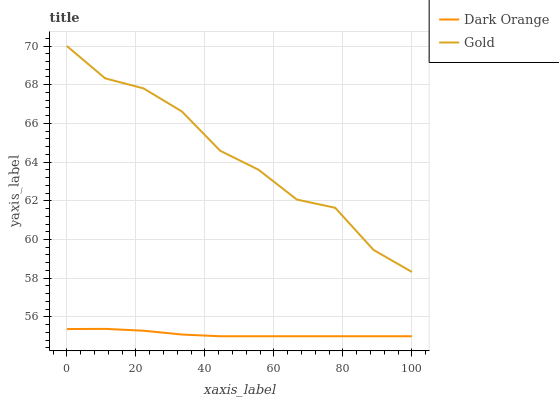Does Dark Orange have the minimum area under the curve?
Answer yes or no. Yes. Does Gold have the maximum area under the curve?
Answer yes or no. Yes. Does Gold have the minimum area under the curve?
Answer yes or no. No. Is Dark Orange the smoothest?
Answer yes or no. Yes. Is Gold the roughest?
Answer yes or no. Yes. Is Gold the smoothest?
Answer yes or no. No. Does Dark Orange have the lowest value?
Answer yes or no. Yes. Does Gold have the lowest value?
Answer yes or no. No. Does Gold have the highest value?
Answer yes or no. Yes. Is Dark Orange less than Gold?
Answer yes or no. Yes. Is Gold greater than Dark Orange?
Answer yes or no. Yes. Does Dark Orange intersect Gold?
Answer yes or no. No. 